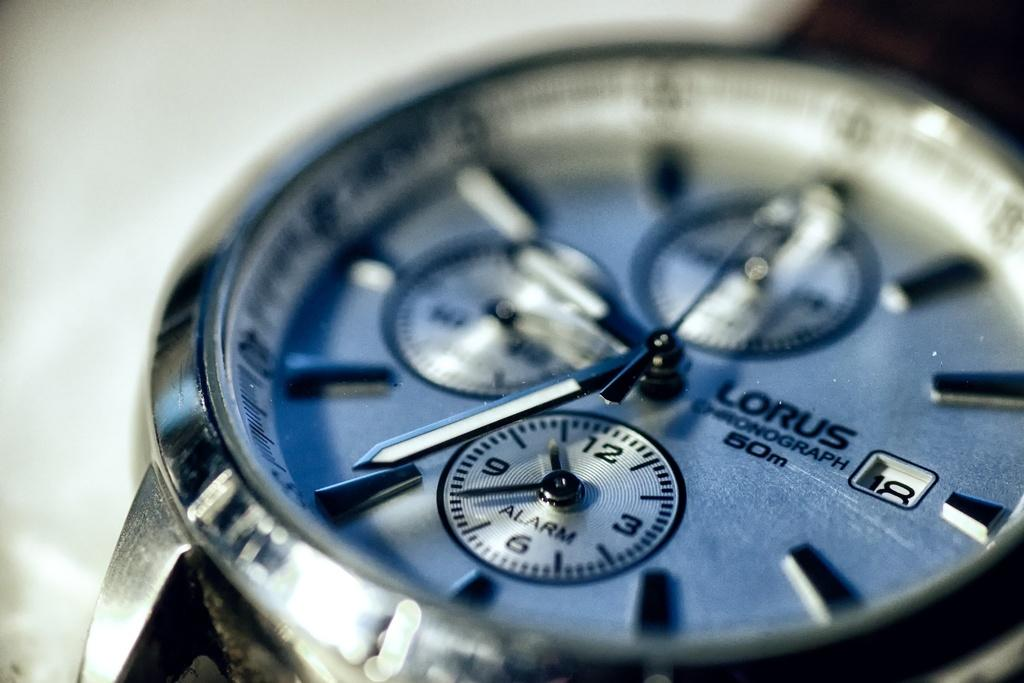<image>
Describe the image concisely. An up close picture of a Lorus watch with the seconds meter reading an 18. 